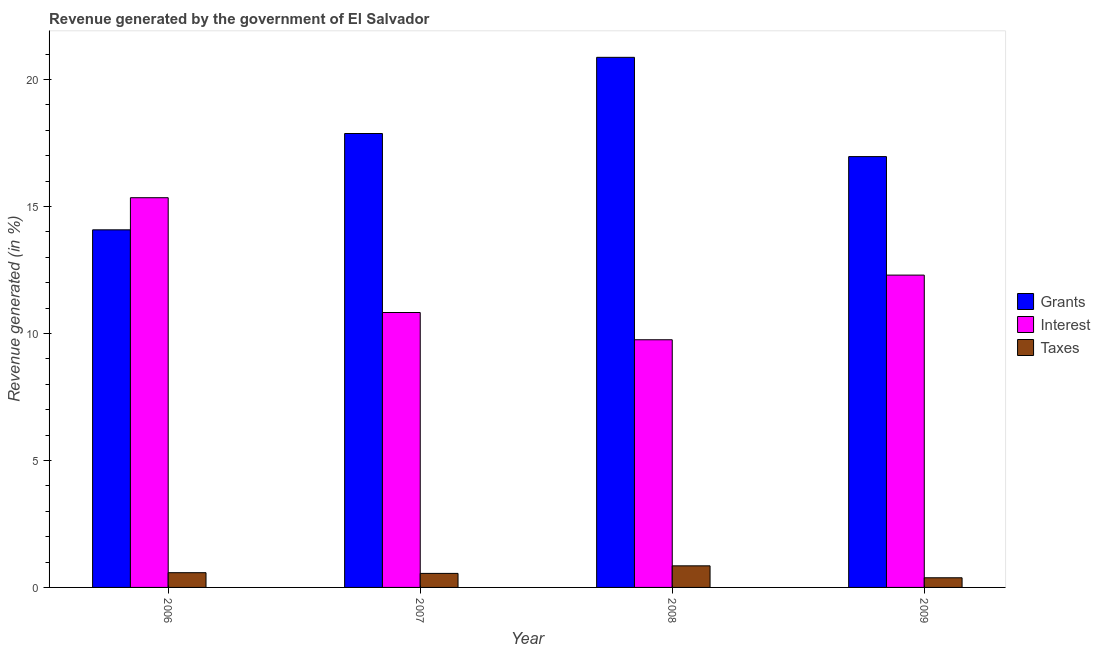How many different coloured bars are there?
Ensure brevity in your answer.  3. Are the number of bars on each tick of the X-axis equal?
Offer a terse response. Yes. How many bars are there on the 2nd tick from the left?
Keep it short and to the point. 3. What is the label of the 1st group of bars from the left?
Ensure brevity in your answer.  2006. What is the percentage of revenue generated by grants in 2007?
Make the answer very short. 17.88. Across all years, what is the maximum percentage of revenue generated by interest?
Make the answer very short. 15.35. Across all years, what is the minimum percentage of revenue generated by grants?
Make the answer very short. 14.08. In which year was the percentage of revenue generated by taxes minimum?
Make the answer very short. 2009. What is the total percentage of revenue generated by interest in the graph?
Offer a very short reply. 48.23. What is the difference between the percentage of revenue generated by taxes in 2006 and that in 2007?
Your response must be concise. 0.03. What is the difference between the percentage of revenue generated by grants in 2008 and the percentage of revenue generated by taxes in 2009?
Your response must be concise. 3.91. What is the average percentage of revenue generated by grants per year?
Make the answer very short. 17.45. In how many years, is the percentage of revenue generated by interest greater than 3 %?
Give a very brief answer. 4. What is the ratio of the percentage of revenue generated by grants in 2006 to that in 2009?
Your answer should be compact. 0.83. Is the percentage of revenue generated by interest in 2007 less than that in 2008?
Make the answer very short. No. Is the difference between the percentage of revenue generated by grants in 2008 and 2009 greater than the difference between the percentage of revenue generated by interest in 2008 and 2009?
Offer a terse response. No. What is the difference between the highest and the second highest percentage of revenue generated by taxes?
Provide a succinct answer. 0.27. What is the difference between the highest and the lowest percentage of revenue generated by taxes?
Offer a very short reply. 0.47. In how many years, is the percentage of revenue generated by taxes greater than the average percentage of revenue generated by taxes taken over all years?
Provide a short and direct response. 1. What does the 1st bar from the left in 2008 represents?
Ensure brevity in your answer.  Grants. What does the 3rd bar from the right in 2008 represents?
Provide a short and direct response. Grants. Is it the case that in every year, the sum of the percentage of revenue generated by grants and percentage of revenue generated by interest is greater than the percentage of revenue generated by taxes?
Provide a short and direct response. Yes. Does the graph contain any zero values?
Provide a short and direct response. No. Does the graph contain grids?
Offer a very short reply. No. How many legend labels are there?
Provide a succinct answer. 3. How are the legend labels stacked?
Keep it short and to the point. Vertical. What is the title of the graph?
Your answer should be very brief. Revenue generated by the government of El Salvador. What is the label or title of the X-axis?
Give a very brief answer. Year. What is the label or title of the Y-axis?
Your answer should be compact. Revenue generated (in %). What is the Revenue generated (in %) of Grants in 2006?
Your answer should be very brief. 14.08. What is the Revenue generated (in %) of Interest in 2006?
Your answer should be compact. 15.35. What is the Revenue generated (in %) in Taxes in 2006?
Make the answer very short. 0.58. What is the Revenue generated (in %) in Grants in 2007?
Ensure brevity in your answer.  17.88. What is the Revenue generated (in %) of Interest in 2007?
Provide a short and direct response. 10.83. What is the Revenue generated (in %) of Taxes in 2007?
Provide a succinct answer. 0.55. What is the Revenue generated (in %) of Grants in 2008?
Make the answer very short. 20.88. What is the Revenue generated (in %) in Interest in 2008?
Ensure brevity in your answer.  9.75. What is the Revenue generated (in %) in Taxes in 2008?
Provide a succinct answer. 0.85. What is the Revenue generated (in %) in Grants in 2009?
Provide a succinct answer. 16.97. What is the Revenue generated (in %) of Interest in 2009?
Keep it short and to the point. 12.3. What is the Revenue generated (in %) in Taxes in 2009?
Give a very brief answer. 0.38. Across all years, what is the maximum Revenue generated (in %) of Grants?
Provide a short and direct response. 20.88. Across all years, what is the maximum Revenue generated (in %) of Interest?
Keep it short and to the point. 15.35. Across all years, what is the maximum Revenue generated (in %) of Taxes?
Offer a very short reply. 0.85. Across all years, what is the minimum Revenue generated (in %) of Grants?
Offer a very short reply. 14.08. Across all years, what is the minimum Revenue generated (in %) in Interest?
Provide a short and direct response. 9.75. Across all years, what is the minimum Revenue generated (in %) in Taxes?
Keep it short and to the point. 0.38. What is the total Revenue generated (in %) in Grants in the graph?
Your answer should be compact. 69.8. What is the total Revenue generated (in %) of Interest in the graph?
Provide a short and direct response. 48.23. What is the total Revenue generated (in %) of Taxes in the graph?
Your response must be concise. 2.36. What is the difference between the Revenue generated (in %) in Grants in 2006 and that in 2007?
Give a very brief answer. -3.79. What is the difference between the Revenue generated (in %) of Interest in 2006 and that in 2007?
Offer a terse response. 4.52. What is the difference between the Revenue generated (in %) of Taxes in 2006 and that in 2007?
Your answer should be very brief. 0.03. What is the difference between the Revenue generated (in %) of Grants in 2006 and that in 2008?
Ensure brevity in your answer.  -6.79. What is the difference between the Revenue generated (in %) of Interest in 2006 and that in 2008?
Make the answer very short. 5.59. What is the difference between the Revenue generated (in %) in Taxes in 2006 and that in 2008?
Provide a succinct answer. -0.27. What is the difference between the Revenue generated (in %) in Grants in 2006 and that in 2009?
Offer a terse response. -2.88. What is the difference between the Revenue generated (in %) of Interest in 2006 and that in 2009?
Give a very brief answer. 3.05. What is the difference between the Revenue generated (in %) in Taxes in 2006 and that in 2009?
Offer a very short reply. 0.2. What is the difference between the Revenue generated (in %) of Grants in 2007 and that in 2008?
Offer a terse response. -3. What is the difference between the Revenue generated (in %) of Interest in 2007 and that in 2008?
Offer a terse response. 1.07. What is the difference between the Revenue generated (in %) of Taxes in 2007 and that in 2008?
Offer a very short reply. -0.3. What is the difference between the Revenue generated (in %) in Grants in 2007 and that in 2009?
Your answer should be compact. 0.91. What is the difference between the Revenue generated (in %) in Interest in 2007 and that in 2009?
Give a very brief answer. -1.47. What is the difference between the Revenue generated (in %) in Taxes in 2007 and that in 2009?
Your answer should be very brief. 0.17. What is the difference between the Revenue generated (in %) in Grants in 2008 and that in 2009?
Provide a succinct answer. 3.91. What is the difference between the Revenue generated (in %) in Interest in 2008 and that in 2009?
Offer a very short reply. -2.55. What is the difference between the Revenue generated (in %) in Taxes in 2008 and that in 2009?
Make the answer very short. 0.47. What is the difference between the Revenue generated (in %) of Grants in 2006 and the Revenue generated (in %) of Interest in 2007?
Offer a terse response. 3.26. What is the difference between the Revenue generated (in %) of Grants in 2006 and the Revenue generated (in %) of Taxes in 2007?
Your response must be concise. 13.53. What is the difference between the Revenue generated (in %) of Interest in 2006 and the Revenue generated (in %) of Taxes in 2007?
Your answer should be compact. 14.8. What is the difference between the Revenue generated (in %) of Grants in 2006 and the Revenue generated (in %) of Interest in 2008?
Your response must be concise. 4.33. What is the difference between the Revenue generated (in %) of Grants in 2006 and the Revenue generated (in %) of Taxes in 2008?
Ensure brevity in your answer.  13.23. What is the difference between the Revenue generated (in %) of Interest in 2006 and the Revenue generated (in %) of Taxes in 2008?
Provide a succinct answer. 14.5. What is the difference between the Revenue generated (in %) in Grants in 2006 and the Revenue generated (in %) in Interest in 2009?
Keep it short and to the point. 1.78. What is the difference between the Revenue generated (in %) of Grants in 2006 and the Revenue generated (in %) of Taxes in 2009?
Your response must be concise. 13.7. What is the difference between the Revenue generated (in %) in Interest in 2006 and the Revenue generated (in %) in Taxes in 2009?
Offer a very short reply. 14.97. What is the difference between the Revenue generated (in %) in Grants in 2007 and the Revenue generated (in %) in Interest in 2008?
Offer a terse response. 8.12. What is the difference between the Revenue generated (in %) of Grants in 2007 and the Revenue generated (in %) of Taxes in 2008?
Your response must be concise. 17.03. What is the difference between the Revenue generated (in %) in Interest in 2007 and the Revenue generated (in %) in Taxes in 2008?
Give a very brief answer. 9.98. What is the difference between the Revenue generated (in %) in Grants in 2007 and the Revenue generated (in %) in Interest in 2009?
Offer a very short reply. 5.58. What is the difference between the Revenue generated (in %) of Grants in 2007 and the Revenue generated (in %) of Taxes in 2009?
Offer a very short reply. 17.5. What is the difference between the Revenue generated (in %) of Interest in 2007 and the Revenue generated (in %) of Taxes in 2009?
Provide a short and direct response. 10.45. What is the difference between the Revenue generated (in %) in Grants in 2008 and the Revenue generated (in %) in Interest in 2009?
Give a very brief answer. 8.58. What is the difference between the Revenue generated (in %) of Grants in 2008 and the Revenue generated (in %) of Taxes in 2009?
Provide a short and direct response. 20.5. What is the difference between the Revenue generated (in %) of Interest in 2008 and the Revenue generated (in %) of Taxes in 2009?
Provide a succinct answer. 9.37. What is the average Revenue generated (in %) in Grants per year?
Your response must be concise. 17.45. What is the average Revenue generated (in %) of Interest per year?
Your answer should be compact. 12.06. What is the average Revenue generated (in %) in Taxes per year?
Provide a succinct answer. 0.59. In the year 2006, what is the difference between the Revenue generated (in %) in Grants and Revenue generated (in %) in Interest?
Your answer should be very brief. -1.27. In the year 2006, what is the difference between the Revenue generated (in %) in Grants and Revenue generated (in %) in Taxes?
Provide a succinct answer. 13.5. In the year 2006, what is the difference between the Revenue generated (in %) of Interest and Revenue generated (in %) of Taxes?
Offer a terse response. 14.77. In the year 2007, what is the difference between the Revenue generated (in %) in Grants and Revenue generated (in %) in Interest?
Keep it short and to the point. 7.05. In the year 2007, what is the difference between the Revenue generated (in %) in Grants and Revenue generated (in %) in Taxes?
Offer a very short reply. 17.32. In the year 2007, what is the difference between the Revenue generated (in %) of Interest and Revenue generated (in %) of Taxes?
Ensure brevity in your answer.  10.27. In the year 2008, what is the difference between the Revenue generated (in %) of Grants and Revenue generated (in %) of Interest?
Provide a short and direct response. 11.12. In the year 2008, what is the difference between the Revenue generated (in %) in Grants and Revenue generated (in %) in Taxes?
Provide a succinct answer. 20.03. In the year 2008, what is the difference between the Revenue generated (in %) of Interest and Revenue generated (in %) of Taxes?
Give a very brief answer. 8.9. In the year 2009, what is the difference between the Revenue generated (in %) of Grants and Revenue generated (in %) of Interest?
Offer a very short reply. 4.67. In the year 2009, what is the difference between the Revenue generated (in %) of Grants and Revenue generated (in %) of Taxes?
Your answer should be very brief. 16.59. In the year 2009, what is the difference between the Revenue generated (in %) in Interest and Revenue generated (in %) in Taxes?
Give a very brief answer. 11.92. What is the ratio of the Revenue generated (in %) in Grants in 2006 to that in 2007?
Your answer should be compact. 0.79. What is the ratio of the Revenue generated (in %) in Interest in 2006 to that in 2007?
Make the answer very short. 1.42. What is the ratio of the Revenue generated (in %) in Taxes in 2006 to that in 2007?
Provide a succinct answer. 1.05. What is the ratio of the Revenue generated (in %) of Grants in 2006 to that in 2008?
Your answer should be very brief. 0.67. What is the ratio of the Revenue generated (in %) of Interest in 2006 to that in 2008?
Your answer should be compact. 1.57. What is the ratio of the Revenue generated (in %) in Taxes in 2006 to that in 2008?
Give a very brief answer. 0.68. What is the ratio of the Revenue generated (in %) of Grants in 2006 to that in 2009?
Provide a succinct answer. 0.83. What is the ratio of the Revenue generated (in %) of Interest in 2006 to that in 2009?
Your response must be concise. 1.25. What is the ratio of the Revenue generated (in %) of Taxes in 2006 to that in 2009?
Ensure brevity in your answer.  1.53. What is the ratio of the Revenue generated (in %) in Grants in 2007 to that in 2008?
Provide a succinct answer. 0.86. What is the ratio of the Revenue generated (in %) in Interest in 2007 to that in 2008?
Give a very brief answer. 1.11. What is the ratio of the Revenue generated (in %) of Taxes in 2007 to that in 2008?
Provide a short and direct response. 0.65. What is the ratio of the Revenue generated (in %) in Grants in 2007 to that in 2009?
Offer a very short reply. 1.05. What is the ratio of the Revenue generated (in %) of Interest in 2007 to that in 2009?
Make the answer very short. 0.88. What is the ratio of the Revenue generated (in %) of Taxes in 2007 to that in 2009?
Your response must be concise. 1.45. What is the ratio of the Revenue generated (in %) in Grants in 2008 to that in 2009?
Your answer should be very brief. 1.23. What is the ratio of the Revenue generated (in %) in Interest in 2008 to that in 2009?
Ensure brevity in your answer.  0.79. What is the ratio of the Revenue generated (in %) of Taxes in 2008 to that in 2009?
Keep it short and to the point. 2.24. What is the difference between the highest and the second highest Revenue generated (in %) in Grants?
Provide a succinct answer. 3. What is the difference between the highest and the second highest Revenue generated (in %) of Interest?
Offer a terse response. 3.05. What is the difference between the highest and the second highest Revenue generated (in %) of Taxes?
Keep it short and to the point. 0.27. What is the difference between the highest and the lowest Revenue generated (in %) of Grants?
Offer a very short reply. 6.79. What is the difference between the highest and the lowest Revenue generated (in %) of Interest?
Give a very brief answer. 5.59. What is the difference between the highest and the lowest Revenue generated (in %) of Taxes?
Make the answer very short. 0.47. 